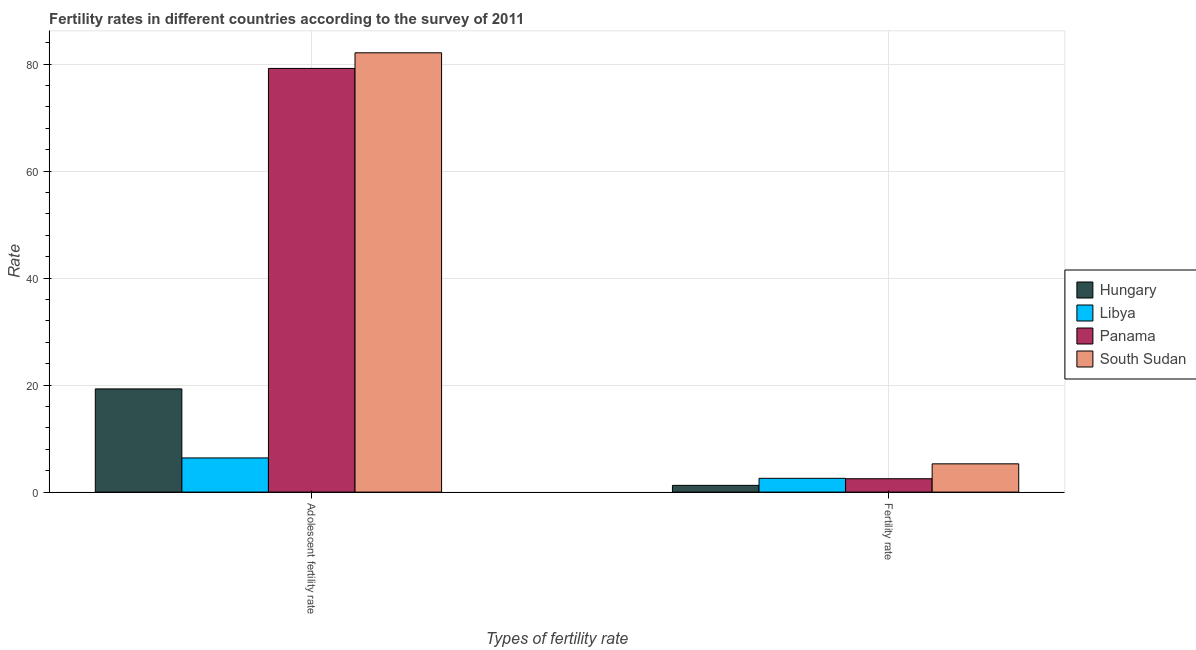How many groups of bars are there?
Ensure brevity in your answer.  2. Are the number of bars per tick equal to the number of legend labels?
Ensure brevity in your answer.  Yes. Are the number of bars on each tick of the X-axis equal?
Your answer should be compact. Yes. How many bars are there on the 1st tick from the left?
Offer a very short reply. 4. What is the label of the 2nd group of bars from the left?
Your answer should be very brief. Fertility rate. What is the adolescent fertility rate in Hungary?
Provide a succinct answer. 19.29. Across all countries, what is the maximum fertility rate?
Your response must be concise. 5.29. Across all countries, what is the minimum fertility rate?
Your answer should be compact. 1.26. In which country was the adolescent fertility rate maximum?
Provide a short and direct response. South Sudan. In which country was the fertility rate minimum?
Your answer should be compact. Hungary. What is the total adolescent fertility rate in the graph?
Keep it short and to the point. 187.01. What is the difference between the adolescent fertility rate in Hungary and that in Libya?
Give a very brief answer. 12.9. What is the difference between the adolescent fertility rate in South Sudan and the fertility rate in Hungary?
Provide a short and direct response. 80.87. What is the average adolescent fertility rate per country?
Your answer should be compact. 46.75. What is the difference between the fertility rate and adolescent fertility rate in Hungary?
Give a very brief answer. -18.03. In how many countries, is the adolescent fertility rate greater than 4 ?
Provide a short and direct response. 4. What is the ratio of the fertility rate in Libya to that in South Sudan?
Give a very brief answer. 0.49. Is the adolescent fertility rate in South Sudan less than that in Hungary?
Offer a very short reply. No. In how many countries, is the adolescent fertility rate greater than the average adolescent fertility rate taken over all countries?
Your answer should be very brief. 2. What does the 1st bar from the left in Fertility rate represents?
Ensure brevity in your answer.  Hungary. What does the 2nd bar from the right in Fertility rate represents?
Ensure brevity in your answer.  Panama. How many bars are there?
Offer a terse response. 8. Are all the bars in the graph horizontal?
Your response must be concise. No. How many countries are there in the graph?
Provide a succinct answer. 4. What is the difference between two consecutive major ticks on the Y-axis?
Offer a terse response. 20. Are the values on the major ticks of Y-axis written in scientific E-notation?
Your response must be concise. No. Does the graph contain any zero values?
Ensure brevity in your answer.  No. Does the graph contain grids?
Ensure brevity in your answer.  Yes. Where does the legend appear in the graph?
Your answer should be very brief. Center right. How are the legend labels stacked?
Provide a succinct answer. Vertical. What is the title of the graph?
Offer a very short reply. Fertility rates in different countries according to the survey of 2011. Does "Chad" appear as one of the legend labels in the graph?
Your response must be concise. No. What is the label or title of the X-axis?
Ensure brevity in your answer.  Types of fertility rate. What is the label or title of the Y-axis?
Keep it short and to the point. Rate. What is the Rate of Hungary in Adolescent fertility rate?
Make the answer very short. 19.29. What is the Rate of Libya in Adolescent fertility rate?
Your answer should be compact. 6.39. What is the Rate in Panama in Adolescent fertility rate?
Offer a very short reply. 79.2. What is the Rate in South Sudan in Adolescent fertility rate?
Ensure brevity in your answer.  82.13. What is the Rate of Hungary in Fertility rate?
Your answer should be compact. 1.26. What is the Rate of Libya in Fertility rate?
Offer a terse response. 2.58. What is the Rate in South Sudan in Fertility rate?
Offer a very short reply. 5.29. Across all Types of fertility rate, what is the maximum Rate of Hungary?
Keep it short and to the point. 19.29. Across all Types of fertility rate, what is the maximum Rate in Libya?
Give a very brief answer. 6.39. Across all Types of fertility rate, what is the maximum Rate in Panama?
Your answer should be very brief. 79.2. Across all Types of fertility rate, what is the maximum Rate of South Sudan?
Your answer should be compact. 82.13. Across all Types of fertility rate, what is the minimum Rate in Hungary?
Provide a succinct answer. 1.26. Across all Types of fertility rate, what is the minimum Rate of Libya?
Make the answer very short. 2.58. Across all Types of fertility rate, what is the minimum Rate in Panama?
Provide a short and direct response. 2.5. Across all Types of fertility rate, what is the minimum Rate in South Sudan?
Ensure brevity in your answer.  5.29. What is the total Rate of Hungary in the graph?
Offer a terse response. 20.55. What is the total Rate of Libya in the graph?
Your answer should be very brief. 8.97. What is the total Rate in Panama in the graph?
Ensure brevity in your answer.  81.7. What is the total Rate of South Sudan in the graph?
Make the answer very short. 87.41. What is the difference between the Rate in Hungary in Adolescent fertility rate and that in Fertility rate?
Ensure brevity in your answer.  18.03. What is the difference between the Rate of Libya in Adolescent fertility rate and that in Fertility rate?
Keep it short and to the point. 3.81. What is the difference between the Rate of Panama in Adolescent fertility rate and that in Fertility rate?
Make the answer very short. 76.7. What is the difference between the Rate in South Sudan in Adolescent fertility rate and that in Fertility rate?
Offer a terse response. 76.84. What is the difference between the Rate in Hungary in Adolescent fertility rate and the Rate in Libya in Fertility rate?
Provide a succinct answer. 16.72. What is the difference between the Rate of Hungary in Adolescent fertility rate and the Rate of Panama in Fertility rate?
Your response must be concise. 16.79. What is the difference between the Rate in Hungary in Adolescent fertility rate and the Rate in South Sudan in Fertility rate?
Provide a succinct answer. 14.01. What is the difference between the Rate in Libya in Adolescent fertility rate and the Rate in Panama in Fertility rate?
Your response must be concise. 3.89. What is the difference between the Rate in Libya in Adolescent fertility rate and the Rate in South Sudan in Fertility rate?
Your response must be concise. 1.1. What is the difference between the Rate in Panama in Adolescent fertility rate and the Rate in South Sudan in Fertility rate?
Offer a terse response. 73.92. What is the average Rate in Hungary per Types of fertility rate?
Your answer should be very brief. 10.28. What is the average Rate in Libya per Types of fertility rate?
Provide a short and direct response. 4.48. What is the average Rate of Panama per Types of fertility rate?
Your answer should be compact. 40.85. What is the average Rate of South Sudan per Types of fertility rate?
Make the answer very short. 43.71. What is the difference between the Rate of Hungary and Rate of Libya in Adolescent fertility rate?
Your answer should be compact. 12.9. What is the difference between the Rate in Hungary and Rate in Panama in Adolescent fertility rate?
Your response must be concise. -59.91. What is the difference between the Rate of Hungary and Rate of South Sudan in Adolescent fertility rate?
Your answer should be very brief. -62.83. What is the difference between the Rate of Libya and Rate of Panama in Adolescent fertility rate?
Offer a terse response. -72.81. What is the difference between the Rate of Libya and Rate of South Sudan in Adolescent fertility rate?
Give a very brief answer. -75.74. What is the difference between the Rate in Panama and Rate in South Sudan in Adolescent fertility rate?
Your answer should be compact. -2.92. What is the difference between the Rate of Hungary and Rate of Libya in Fertility rate?
Offer a terse response. -1.32. What is the difference between the Rate of Hungary and Rate of Panama in Fertility rate?
Give a very brief answer. -1.24. What is the difference between the Rate in Hungary and Rate in South Sudan in Fertility rate?
Offer a very short reply. -4.03. What is the difference between the Rate in Libya and Rate in Panama in Fertility rate?
Your response must be concise. 0.08. What is the difference between the Rate in Libya and Rate in South Sudan in Fertility rate?
Your answer should be compact. -2.71. What is the difference between the Rate of Panama and Rate of South Sudan in Fertility rate?
Offer a very short reply. -2.79. What is the ratio of the Rate of Hungary in Adolescent fertility rate to that in Fertility rate?
Your answer should be compact. 15.31. What is the ratio of the Rate in Libya in Adolescent fertility rate to that in Fertility rate?
Keep it short and to the point. 2.48. What is the ratio of the Rate of Panama in Adolescent fertility rate to that in Fertility rate?
Ensure brevity in your answer.  31.68. What is the ratio of the Rate in South Sudan in Adolescent fertility rate to that in Fertility rate?
Give a very brief answer. 15.54. What is the difference between the highest and the second highest Rate in Hungary?
Your response must be concise. 18.03. What is the difference between the highest and the second highest Rate of Libya?
Give a very brief answer. 3.81. What is the difference between the highest and the second highest Rate in Panama?
Provide a short and direct response. 76.7. What is the difference between the highest and the second highest Rate in South Sudan?
Your response must be concise. 76.84. What is the difference between the highest and the lowest Rate of Hungary?
Offer a terse response. 18.03. What is the difference between the highest and the lowest Rate in Libya?
Offer a terse response. 3.81. What is the difference between the highest and the lowest Rate of Panama?
Give a very brief answer. 76.7. What is the difference between the highest and the lowest Rate in South Sudan?
Ensure brevity in your answer.  76.84. 